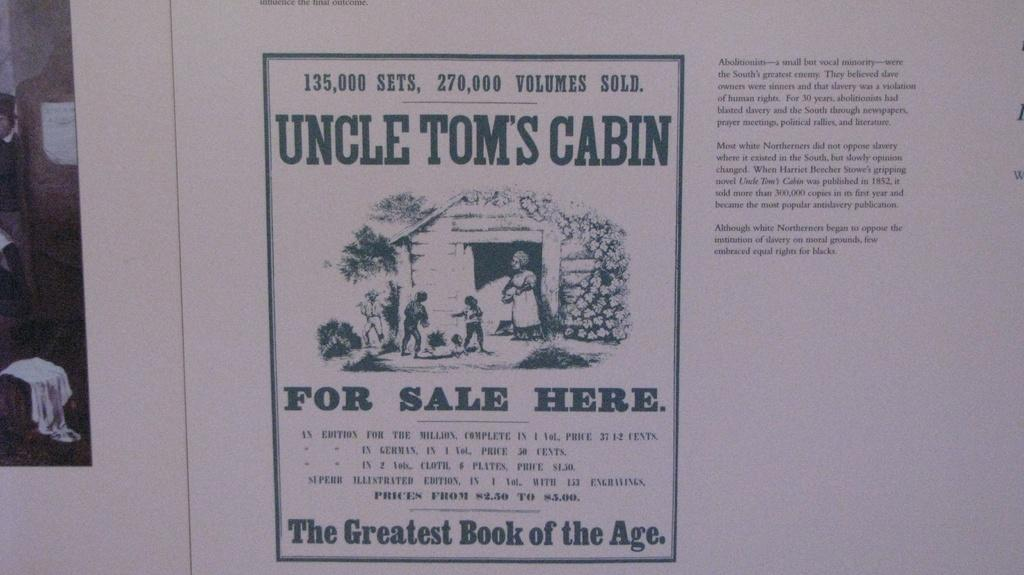<image>
Provide a brief description of the given image. Paper that says "Uncle Tom's Cabin which is 135,000 sets. 